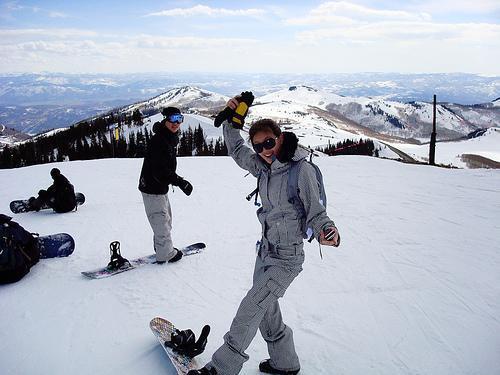How many people on the snow?
Give a very brief answer. 3. 